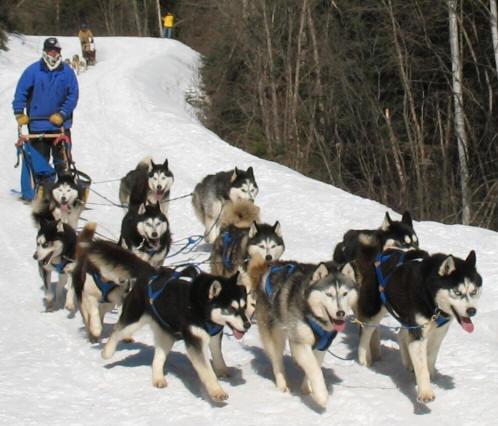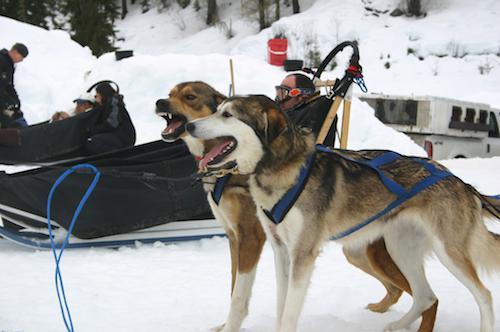The first image is the image on the left, the second image is the image on the right. For the images displayed, is the sentence "The left image contains no more than two sled dogs." factually correct? Answer yes or no. No. The first image is the image on the left, the second image is the image on the right. For the images displayed, is the sentence "Two dogs are connected to reins in the image on the left." factually correct? Answer yes or no. No. 